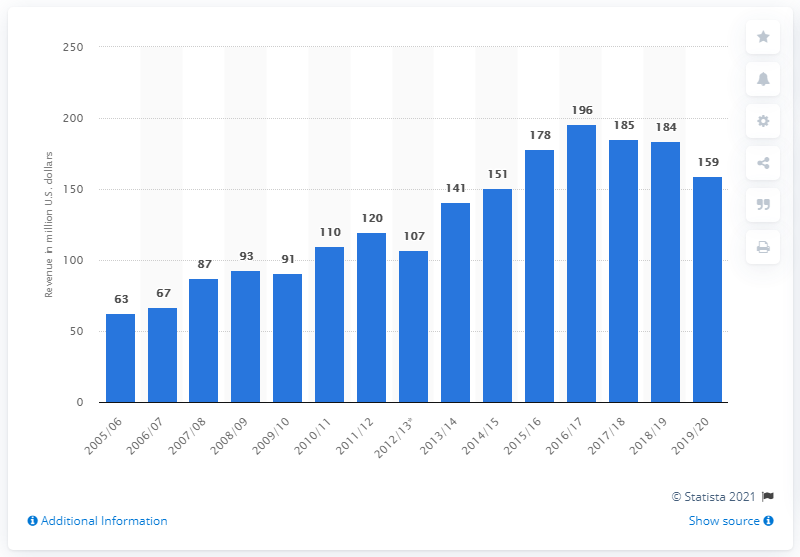Identify some key points in this picture. The Pittsburgh Penguins made a substantial amount of money in the 2019/20 season, totaling 159 million dollars. 